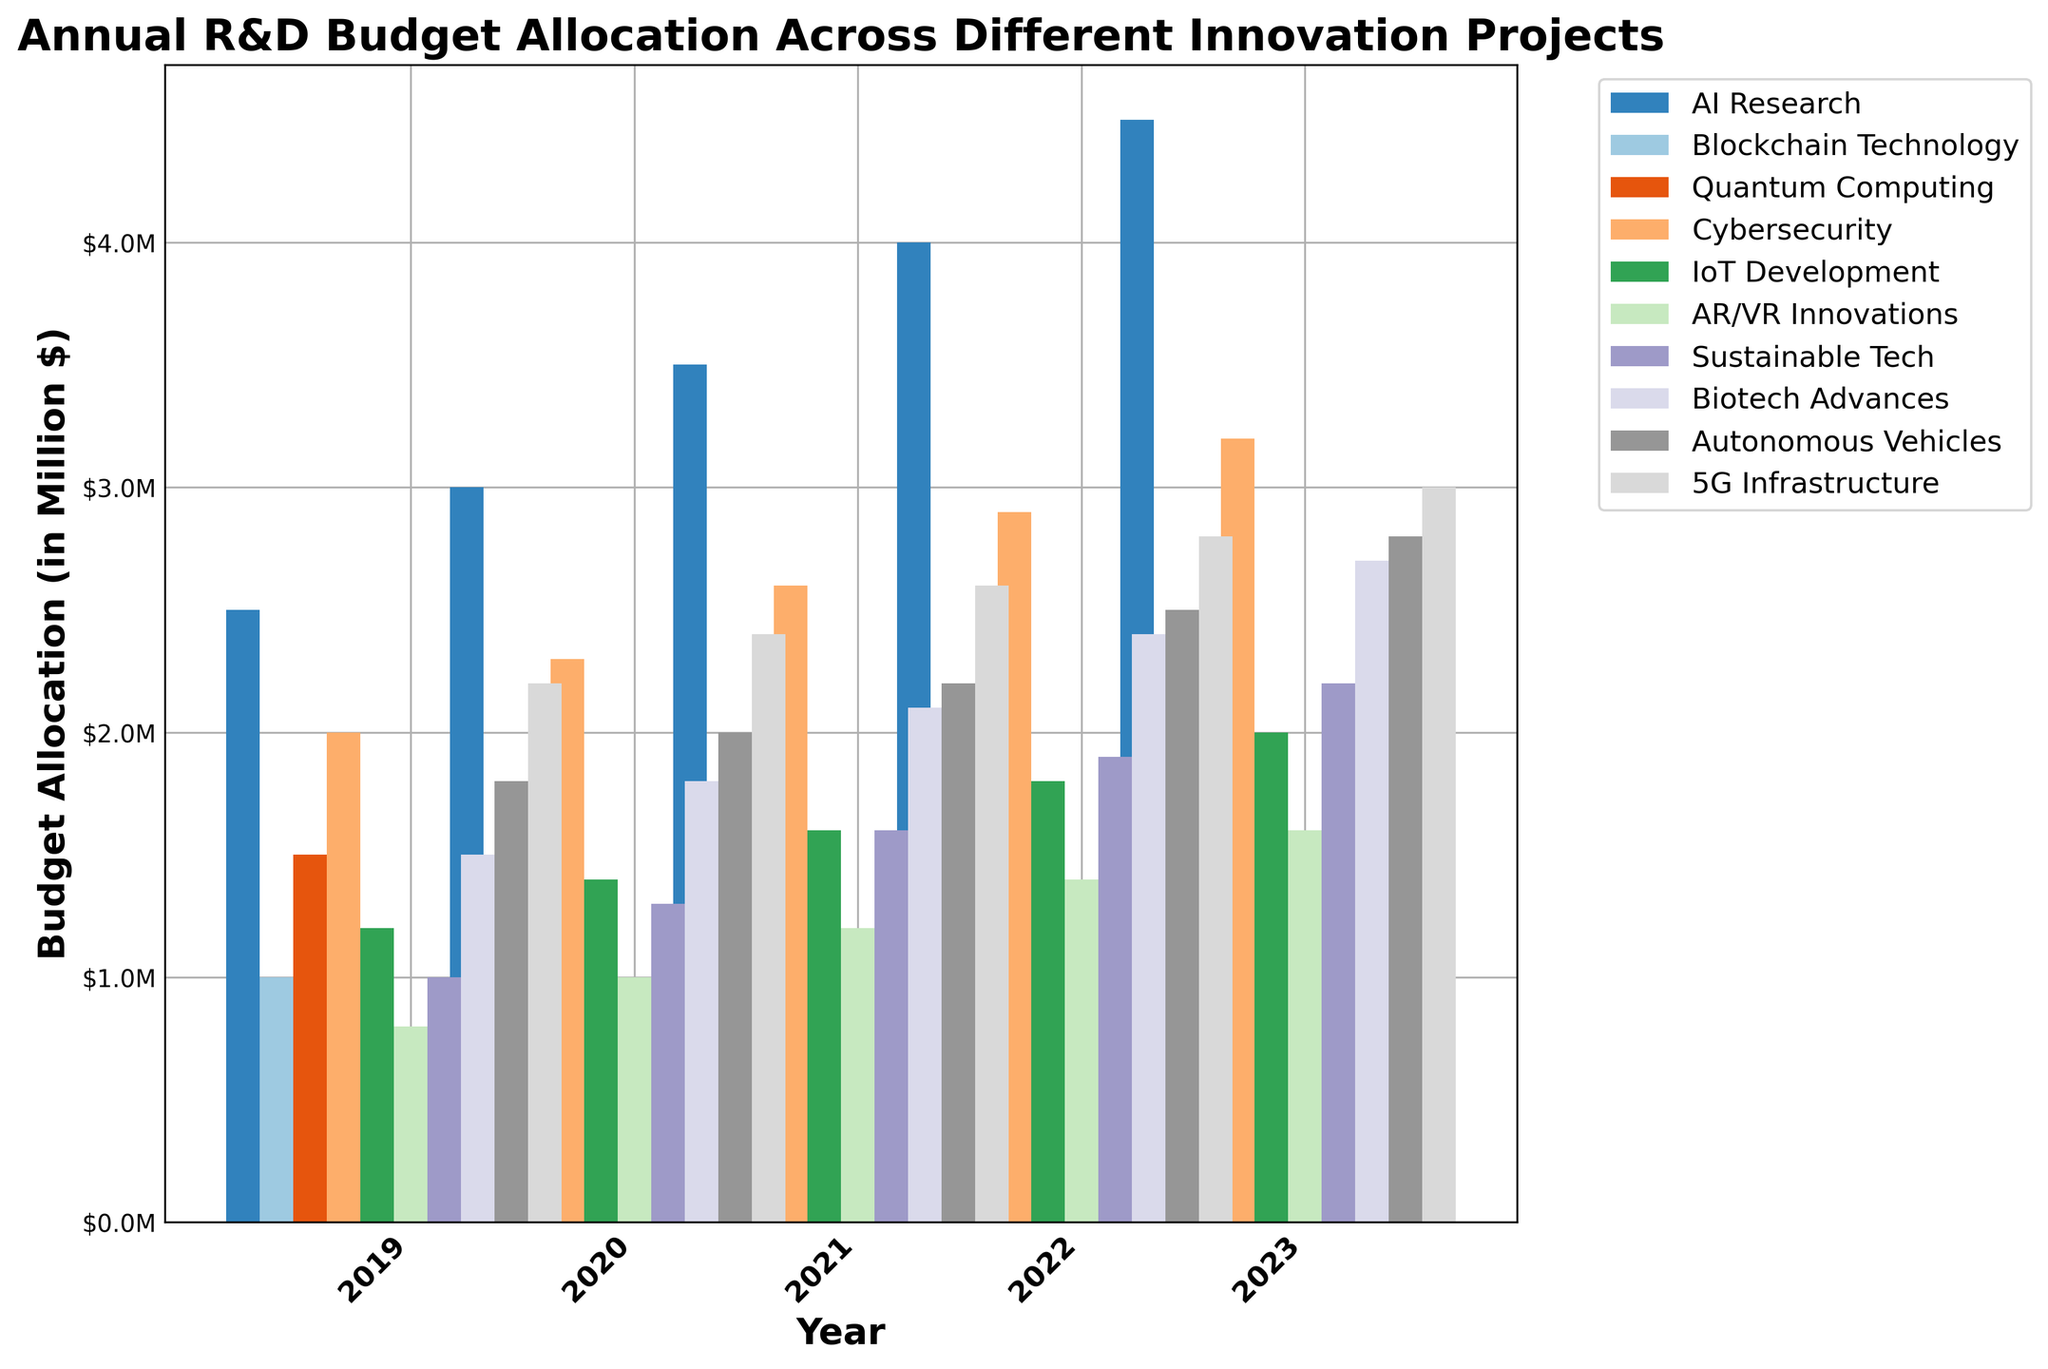What's the total R&D budget allocation for AI Research over the five years? Calculate the total by summing up the yearly budget allocations for AI Research: 2.5 (2019) + 3.0 (2020) + 3.5 (2021) + 4.0 (2022) + 4.5 (2023) = 17.5.
Answer: 17.5 Which innovation project had the highest budget allocation in 2023? Examine the heights of the bars for each project in 2023 and find the tallest one. "AI Research" has the highest bar at 4.5 million dollars.
Answer: AI Research Compare the budget allocation of Cybersecurity and 5G Infrastructure in 2021. Which one had a higher budget and by how much? Look at the bars for Cybersecurity and 5G Infrastructure in 2021. Cybersecurity was allocated 2.6 million dollars and 5G Infrastructure had 2.6 million dollars, so they had the same budget.
Answer: They had the same budget What was the percentage increase in the R&D budget for Blockchain Technology from 2019 to 2023? Calculate the percentage increase using the formula ((new value - old value) / old value) x 100. For Blockchain Technology, ((1.8 - 1.0) / 1.0) x 100 = 80%.
Answer: 80% Did any project have a consistent year-over-year increase in budget allocation from 2019 to 2023? If so, name the project. Look at the bars for each project and see if there is a continuous increase each year. "AI Research" is one of the projects with a consistent year-over-year increase (2.5, 3.0, 3.5, 4.0, 4.5).
Answer: AI Research Which innovation project had the lowest budget allocation in 2020? Examine the bars for each project in the year 2020 and identify the shortest one. "AR/VR Innovations" had the lowest budget allocation at 1.0 million dollars.
Answer: AR/VR Innovations How does the 2023 budget allocation for Sustainable Tech compare to its allocation in 2021? Look at the bars for Sustainable Tech in 2021 and 2023. In 2021, the allocation was 1.6 million dollars, and in 2023, it was 2.2 million dollars. The 2023 budget is higher by 0.6 million dollars than the 2021 budget.
Answer: 2.2 million dollars higher by 0.6 million dollars In which year did Quantum Computing see the highest increase in R&D budget allocation compared to the previous year? Calculate the yearly increase for Quantum Computing and identify the year with the highest increase: 
2020 (1.7 - 1.5 = 0.2), 
2021 (1.9 - 1.7 = 0.2), 
2022 (2.2 - 1.9 = 0.3), 
2023 (2.5 - 2.2 = 0.3). 
The years 2022 and 2023 both had the highest increase of 0.3 million dollars.
Answer: 2022 and 2023 What is the average annual budget allocation for IoT Development from 2019 to 2023? Calculate the average by summing the yearly data for IoT Development and dividing by 5. (1.2 + 1.4 + 1.6 + 1.8 + 2.0) / 5 = 8.0 / 5 = 1.6 million dollars.
Answer: 1.6 Looking at the visual attributes of the bars for AR/VR Innovations, what can be inferred about its budget trend from 2019 to 2023? Visually observe the bars for AR/VR Innovations from 2019 to 2023. The bars increase in height each year indicating a positive trend in budget allocation (0.8, 1.0, 1.2, 1.4, 1.6).
Answer: Positive trend 